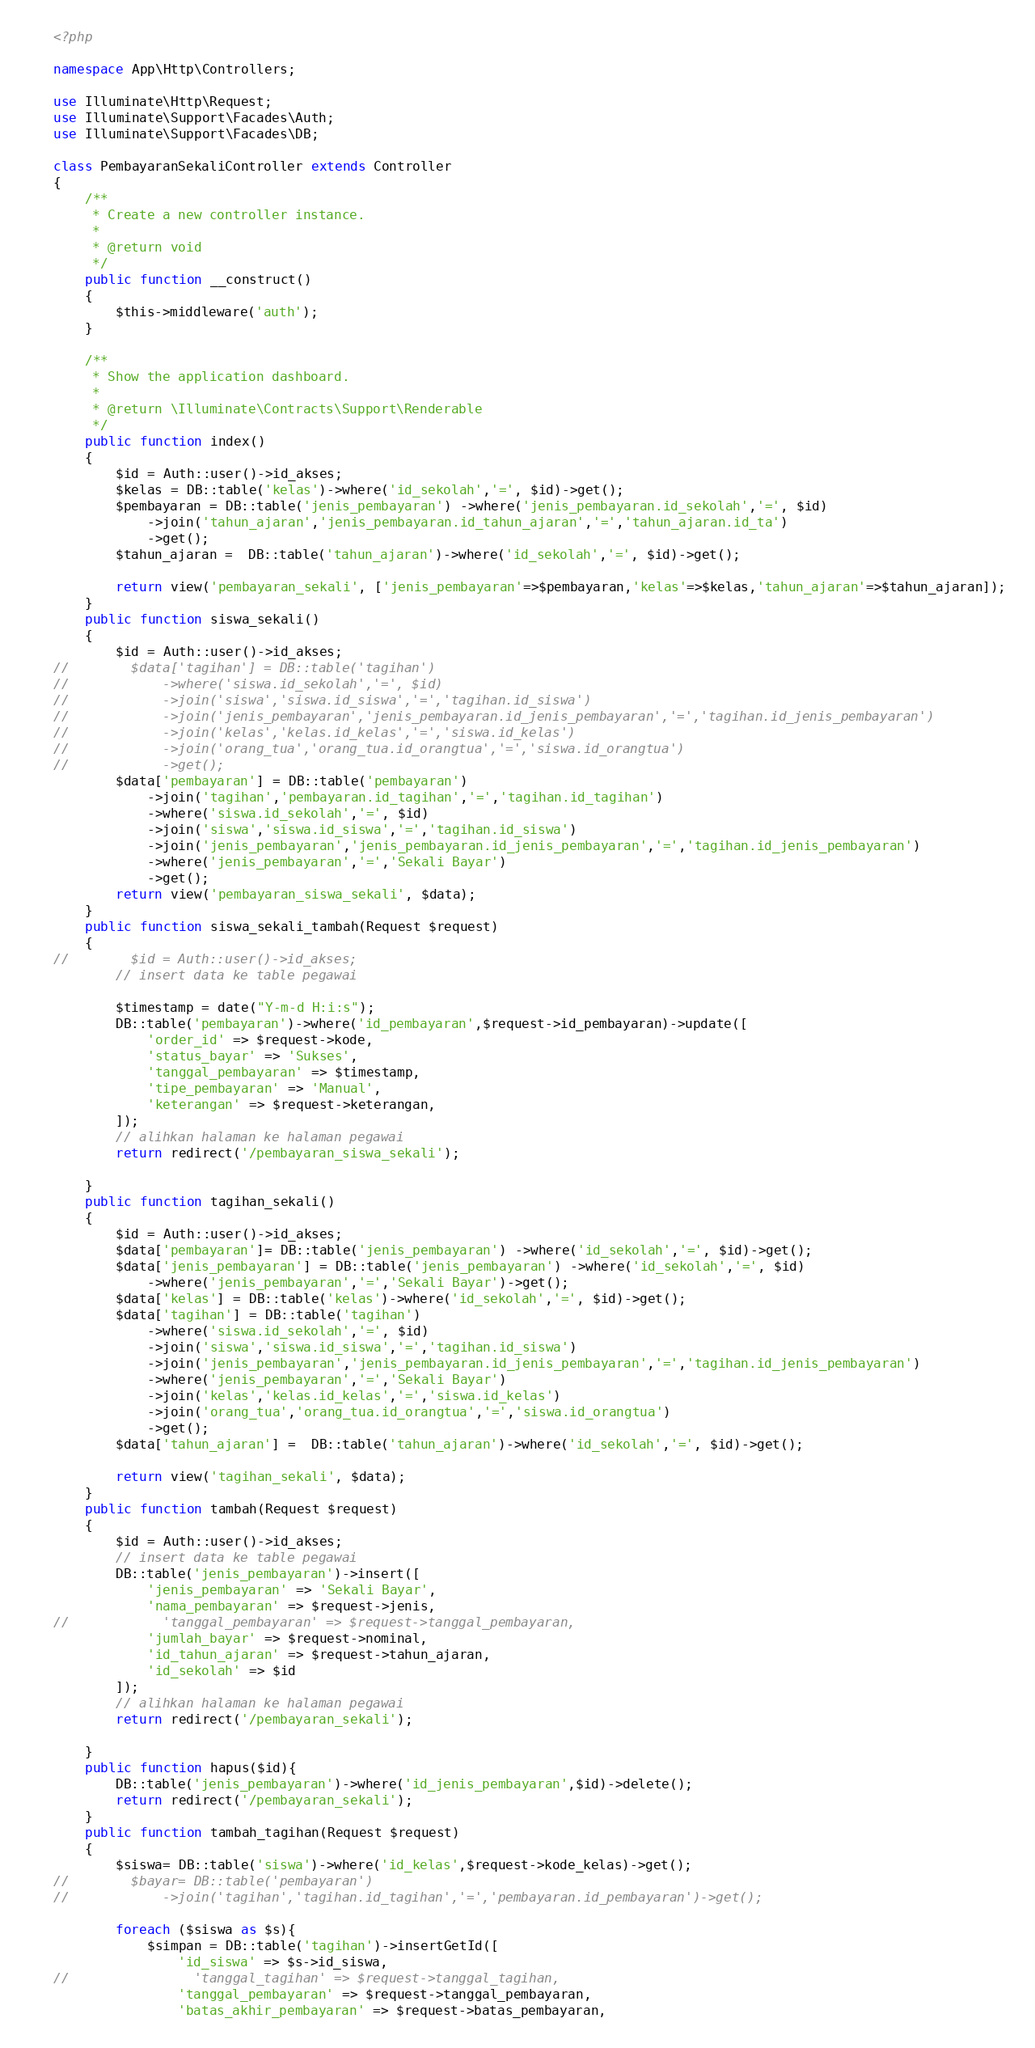Convert code to text. <code><loc_0><loc_0><loc_500><loc_500><_PHP_><?php

namespace App\Http\Controllers;

use Illuminate\Http\Request;
use Illuminate\Support\Facades\Auth;
use Illuminate\Support\Facades\DB;

class PembayaranSekaliController extends Controller
{
    /**
     * Create a new controller instance.
     *
     * @return void
     */
    public function __construct()
    {
        $this->middleware('auth');
    }

    /**
     * Show the application dashboard.
     *
     * @return \Illuminate\Contracts\Support\Renderable
     */
    public function index()
    {
        $id = Auth::user()->id_akses;
        $kelas = DB::table('kelas')->where('id_sekolah','=', $id)->get();
        $pembayaran = DB::table('jenis_pembayaran') ->where('jenis_pembayaran.id_sekolah','=', $id)
            ->join('tahun_ajaran','jenis_pembayaran.id_tahun_ajaran','=','tahun_ajaran.id_ta')
            ->get();
        $tahun_ajaran =  DB::table('tahun_ajaran')->where('id_sekolah','=', $id)->get();

        return view('pembayaran_sekali', ['jenis_pembayaran'=>$pembayaran,'kelas'=>$kelas,'tahun_ajaran'=>$tahun_ajaran]);
    }
    public function siswa_sekali()
    {
        $id = Auth::user()->id_akses;
//        $data['tagihan'] = DB::table('tagihan')
//            ->where('siswa.id_sekolah','=', $id)
//            ->join('siswa','siswa.id_siswa','=','tagihan.id_siswa')
//            ->join('jenis_pembayaran','jenis_pembayaran.id_jenis_pembayaran','=','tagihan.id_jenis_pembayaran')
//            ->join('kelas','kelas.id_kelas','=','siswa.id_kelas')
//            ->join('orang_tua','orang_tua.id_orangtua','=','siswa.id_orangtua')
//            ->get();
        $data['pembayaran'] = DB::table('pembayaran')
            ->join('tagihan','pembayaran.id_tagihan','=','tagihan.id_tagihan')
            ->where('siswa.id_sekolah','=', $id)
            ->join('siswa','siswa.id_siswa','=','tagihan.id_siswa')
            ->join('jenis_pembayaran','jenis_pembayaran.id_jenis_pembayaran','=','tagihan.id_jenis_pembayaran')
            ->where('jenis_pembayaran','=','Sekali Bayar')
            ->get();
        return view('pembayaran_siswa_sekali', $data);
    }
    public function siswa_sekali_tambah(Request $request)
    {
//        $id = Auth::user()->id_akses;
        // insert data ke table pegawai

        $timestamp = date("Y-m-d H:i:s");
        DB::table('pembayaran')->where('id_pembayaran',$request->id_pembayaran)->update([
            'order_id' => $request->kode,
            'status_bayar' => 'Sukses',
            'tanggal_pembayaran' => $timestamp,
            'tipe_pembayaran' => 'Manual',
            'keterangan' => $request->keterangan,
        ]);
        // alihkan halaman ke halaman pegawai
        return redirect('/pembayaran_siswa_sekali');

    }
    public function tagihan_sekali()
    {
        $id = Auth::user()->id_akses;
        $data['pembayaran']= DB::table('jenis_pembayaran') ->where('id_sekolah','=', $id)->get();
        $data['jenis_pembayaran'] = DB::table('jenis_pembayaran') ->where('id_sekolah','=', $id)
            ->where('jenis_pembayaran','=','Sekali Bayar')->get();
        $data['kelas'] = DB::table('kelas')->where('id_sekolah','=', $id)->get();
        $data['tagihan'] = DB::table('tagihan')
            ->where('siswa.id_sekolah','=', $id)
            ->join('siswa','siswa.id_siswa','=','tagihan.id_siswa')
            ->join('jenis_pembayaran','jenis_pembayaran.id_jenis_pembayaran','=','tagihan.id_jenis_pembayaran')
            ->where('jenis_pembayaran','=','Sekali Bayar')
            ->join('kelas','kelas.id_kelas','=','siswa.id_kelas')
            ->join('orang_tua','orang_tua.id_orangtua','=','siswa.id_orangtua')
            ->get();
        $data['tahun_ajaran'] =  DB::table('tahun_ajaran')->where('id_sekolah','=', $id)->get();

        return view('tagihan_sekali', $data);
    }
    public function tambah(Request $request)
    {
        $id = Auth::user()->id_akses;
        // insert data ke table pegawai
        DB::table('jenis_pembayaran')->insert([
            'jenis_pembayaran' => 'Sekali Bayar',
            'nama_pembayaran' => $request->jenis,
//            'tanggal_pembayaran' => $request->tanggal_pembayaran,
            'jumlah_bayar' => $request->nominal,
            'id_tahun_ajaran' => $request->tahun_ajaran,
            'id_sekolah' => $id
        ]);
        // alihkan halaman ke halaman pegawai
        return redirect('/pembayaran_sekali');

    }
    public function hapus($id){
        DB::table('jenis_pembayaran')->where('id_jenis_pembayaran',$id)->delete();
        return redirect('/pembayaran_sekali');
    }
    public function tambah_tagihan(Request $request)
    {
        $siswa= DB::table('siswa')->where('id_kelas',$request->kode_kelas)->get();
//        $bayar= DB::table('pembayaran')
//            ->join('tagihan','tagihan.id_tagihan','=','pembayaran.id_pembayaran')->get();

        foreach ($siswa as $s){
            $simpan = DB::table('tagihan')->insertGetId([
                'id_siswa' => $s->id_siswa,
//                'tanggal_tagihan' => $request->tanggal_tagihan,
                'tanggal_pembayaran' => $request->tanggal_pembayaran,
                'batas_akhir_pembayaran' => $request->batas_pembayaran,</code> 